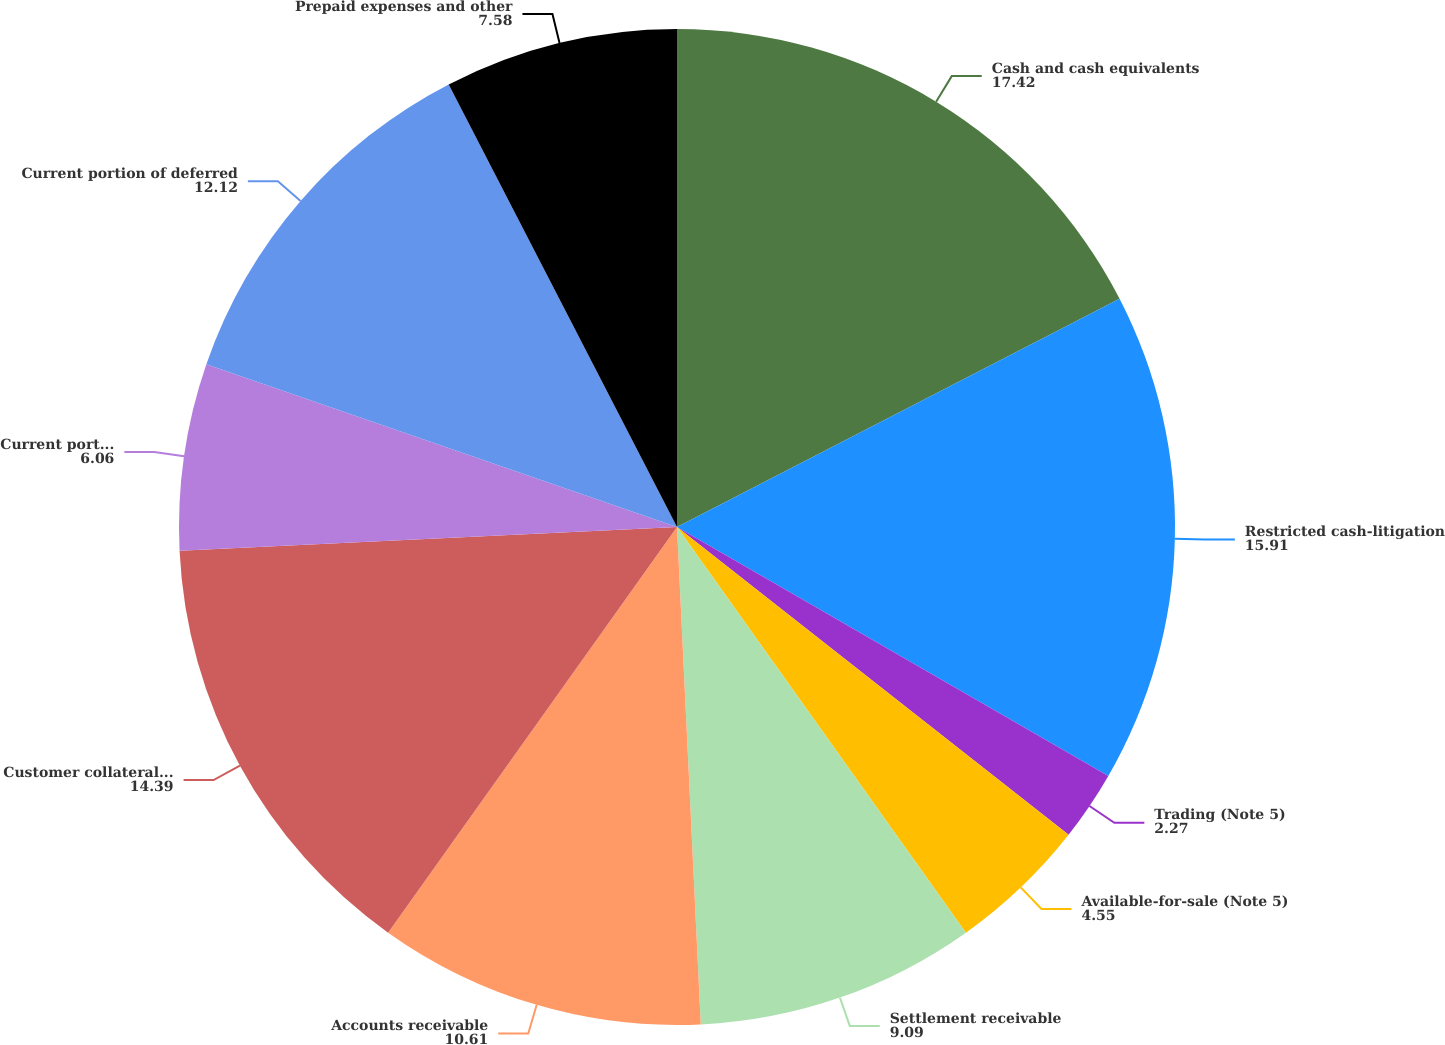<chart> <loc_0><loc_0><loc_500><loc_500><pie_chart><fcel>Cash and cash equivalents<fcel>Restricted cash-litigation<fcel>Trading (Note 5)<fcel>Available-for-sale (Note 5)<fcel>Settlement receivable<fcel>Accounts receivable<fcel>Customer collateral (Note 13)<fcel>Current portion of volume and<fcel>Current portion of deferred<fcel>Prepaid expenses and other<nl><fcel>17.42%<fcel>15.91%<fcel>2.27%<fcel>4.55%<fcel>9.09%<fcel>10.61%<fcel>14.39%<fcel>6.06%<fcel>12.12%<fcel>7.58%<nl></chart> 